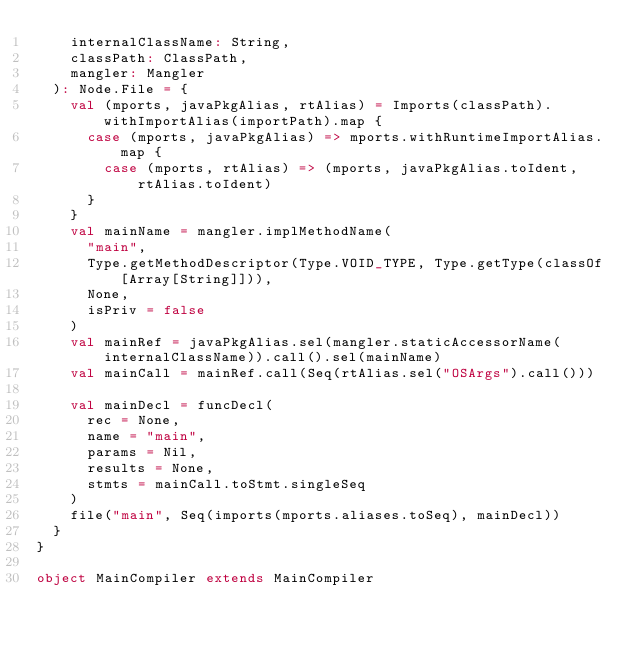<code> <loc_0><loc_0><loc_500><loc_500><_Scala_>    internalClassName: String,
    classPath: ClassPath,
    mangler: Mangler
  ): Node.File = {
    val (mports, javaPkgAlias, rtAlias) = Imports(classPath).withImportAlias(importPath).map {
      case (mports, javaPkgAlias) => mports.withRuntimeImportAlias.map {
        case (mports, rtAlias) => (mports, javaPkgAlias.toIdent, rtAlias.toIdent)
      }
    }
    val mainName = mangler.implMethodName(
      "main",
      Type.getMethodDescriptor(Type.VOID_TYPE, Type.getType(classOf[Array[String]])),
      None,
      isPriv = false
    )
    val mainRef = javaPkgAlias.sel(mangler.staticAccessorName(internalClassName)).call().sel(mainName)
    val mainCall = mainRef.call(Seq(rtAlias.sel("OSArgs").call()))

    val mainDecl = funcDecl(
      rec = None,
      name = "main",
      params = Nil,
      results = None,
      stmts = mainCall.toStmt.singleSeq
    )
    file("main", Seq(imports(mports.aliases.toSeq), mainDecl))
  }
}

object MainCompiler extends MainCompiler
</code> 